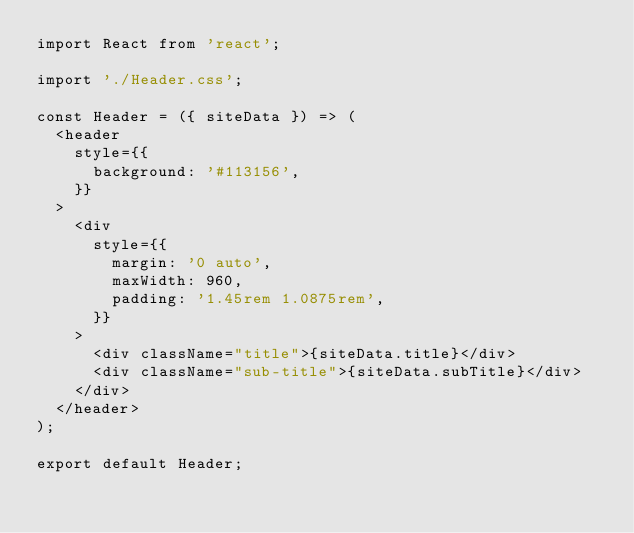<code> <loc_0><loc_0><loc_500><loc_500><_JavaScript_>import React from 'react';

import './Header.css';

const Header = ({ siteData }) => (
  <header
    style={{
      background: '#113156',
    }}
  >
    <div
      style={{
        margin: '0 auto',
        maxWidth: 960,
        padding: '1.45rem 1.0875rem',
      }}
    >
      <div className="title">{siteData.title}</div>
      <div className="sub-title">{siteData.subTitle}</div>
    </div>
  </header>
);

export default Header;
</code> 